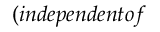Convert formula to latex. <formula><loc_0><loc_0><loc_500><loc_500>( i n d e p e n d e n t o f</formula> 